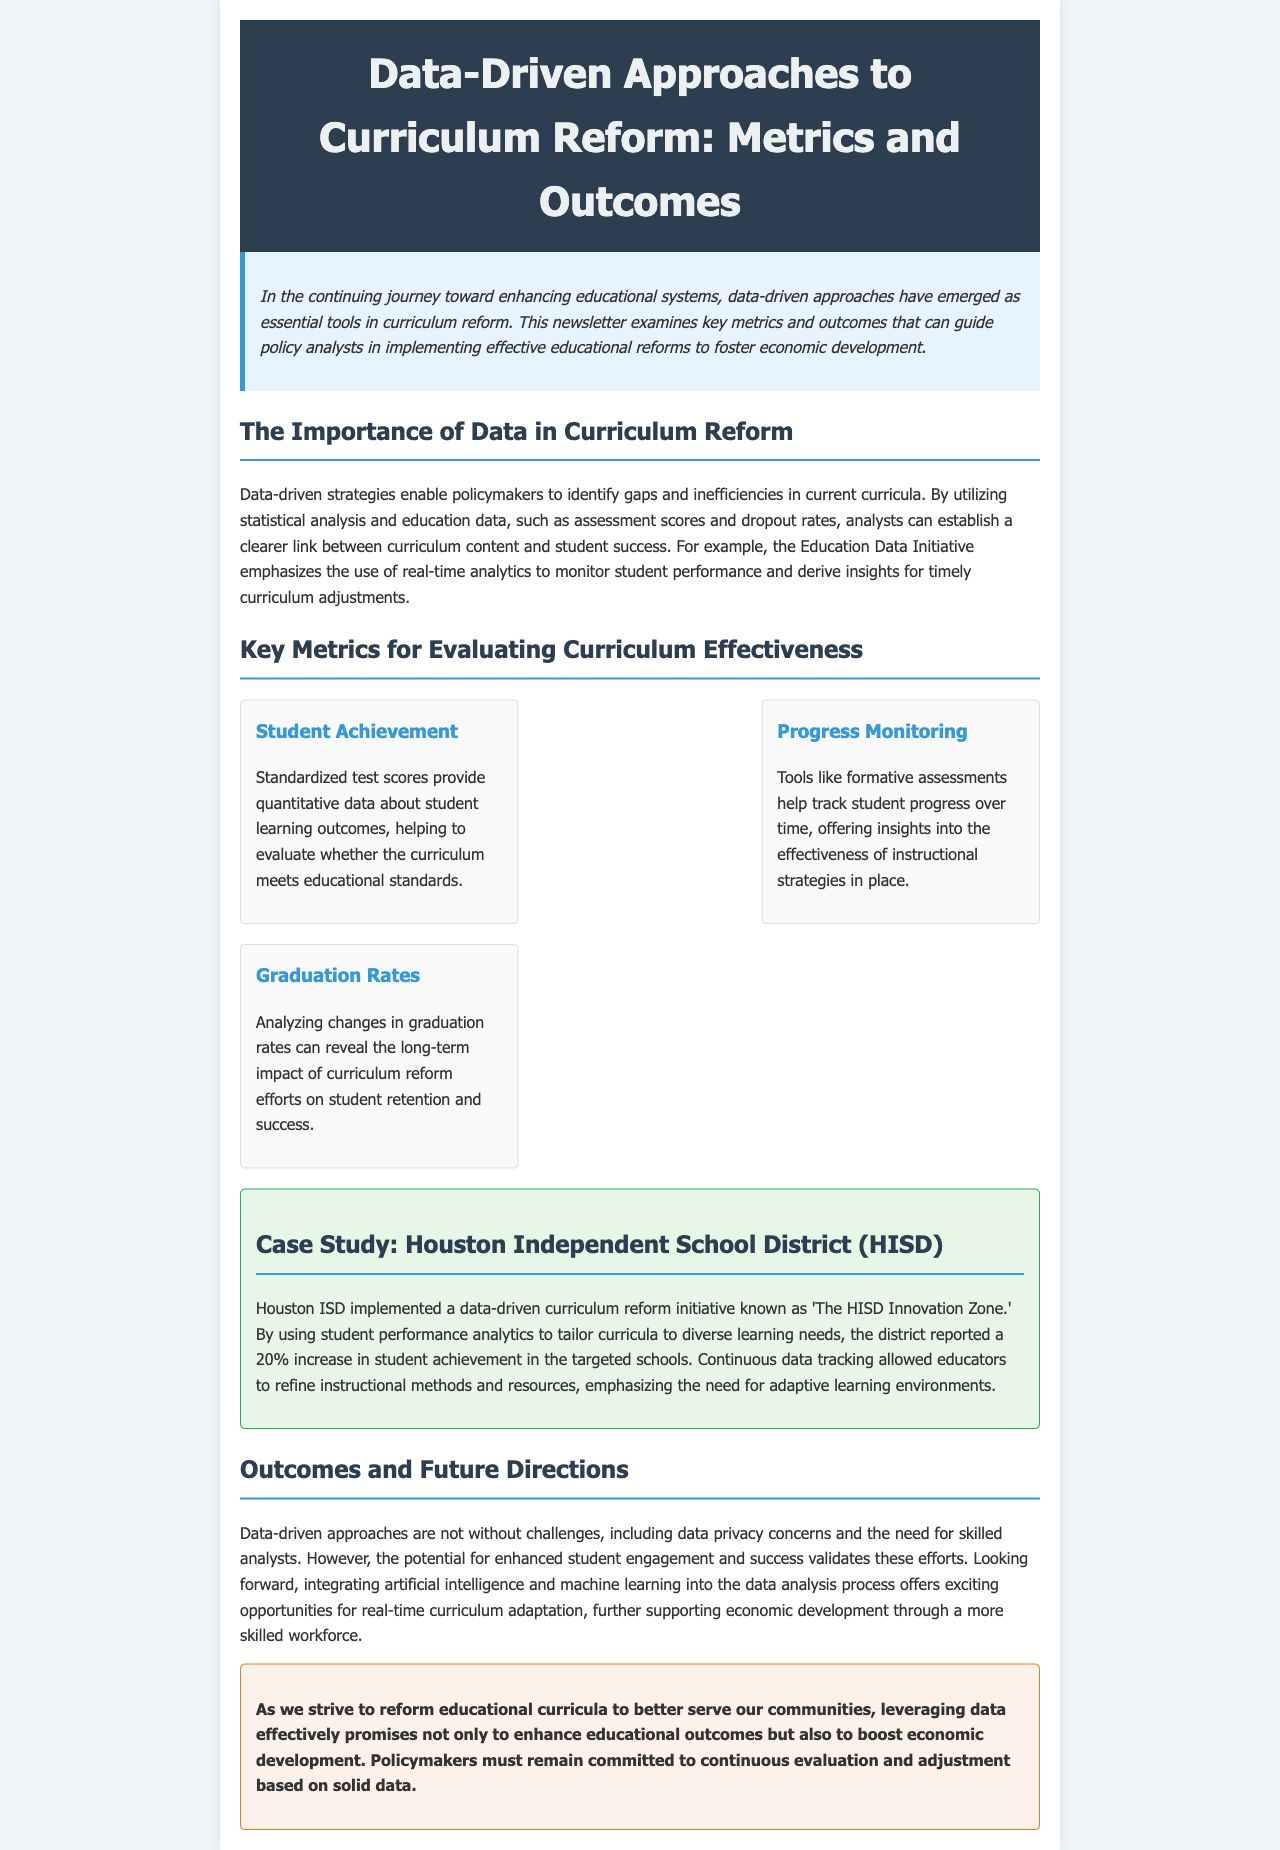What is the main focus of the newsletter? The newsletter focuses on data-driven approaches to curriculum reform and their impact on educational outcomes and economic development.
Answer: Data-driven approaches to curriculum reform What percentage increase in student achievement was reported in the HISD case study? The HISD case study mentions a 20% increase in student achievement due to the curriculum reform initiative.
Answer: 20% What are standardized test scores used to evaluate? Standardized test scores are utilized to provide quantitative data about student learning outcomes and assess whether the curriculum meets educational standards.
Answer: Student learning outcomes What are tools like formative assessments used for? Formative assessments are used to track student progress over time and provide insights into the effectiveness of instructional strategies.
Answer: Track student progress What challenges are mentioned in implementing data-driven approaches? The document highlights data privacy concerns and the necessity for skilled analysts as challenges in implementing data-driven approaches.
Answer: Data privacy concerns and skilled analysts How does the newsletter suggest integrating technology into data analysis? The newsletter mentions that integrating artificial intelligence and machine learning into the data analysis process presents future opportunities for real-time curriculum adaptation.
Answer: Artificial intelligence and machine learning What is the primary goal of leveraging data in curriculum reform according to the conclusion? The conclusion underscores the promise of leveraging data to enhance educational outcomes and promote economic development.
Answer: Enhance educational outcomes and boost economic development 